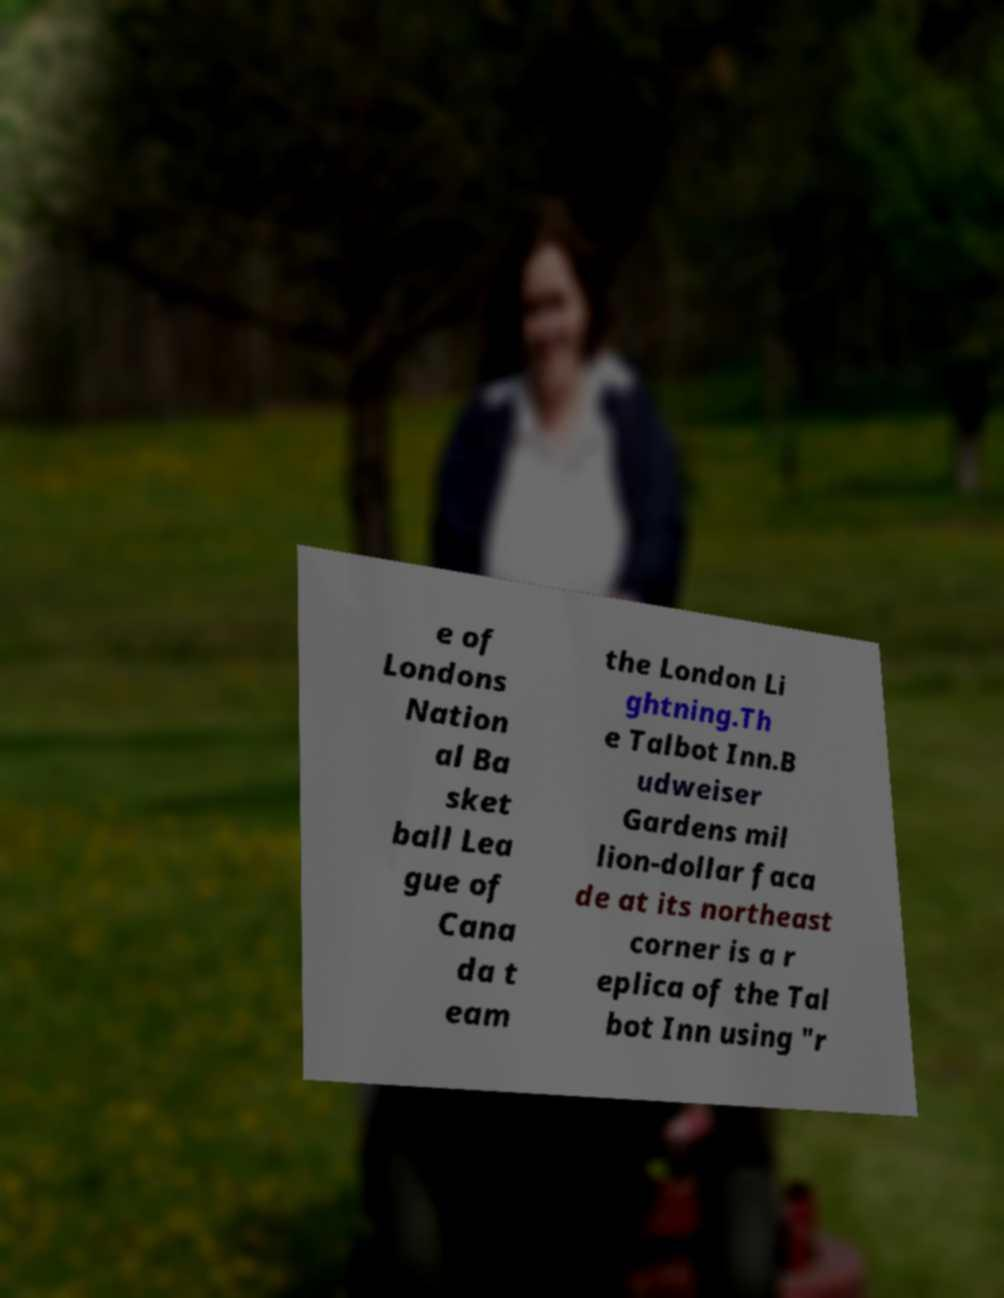Could you extract and type out the text from this image? e of Londons Nation al Ba sket ball Lea gue of Cana da t eam the London Li ghtning.Th e Talbot Inn.B udweiser Gardens mil lion-dollar faca de at its northeast corner is a r eplica of the Tal bot Inn using "r 